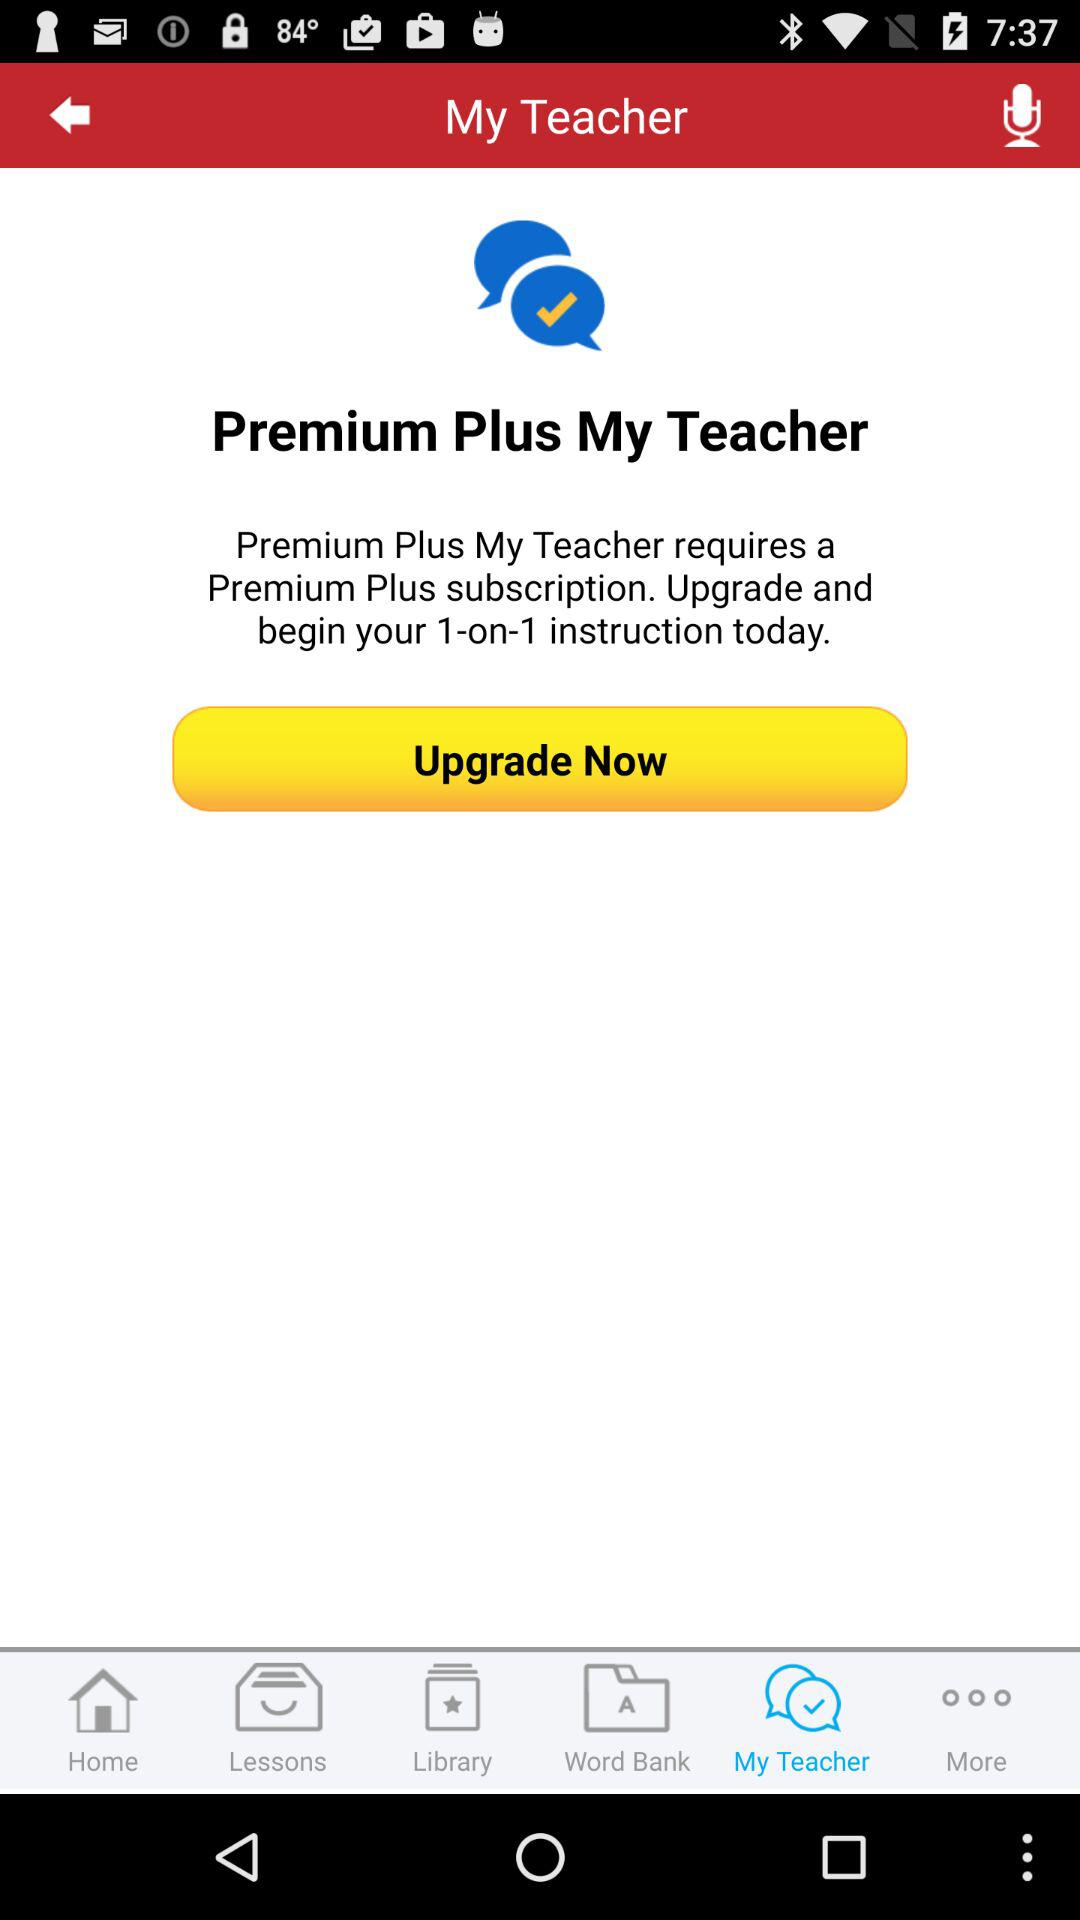Which is the selected tab? The selected tab is "My Teacher". 